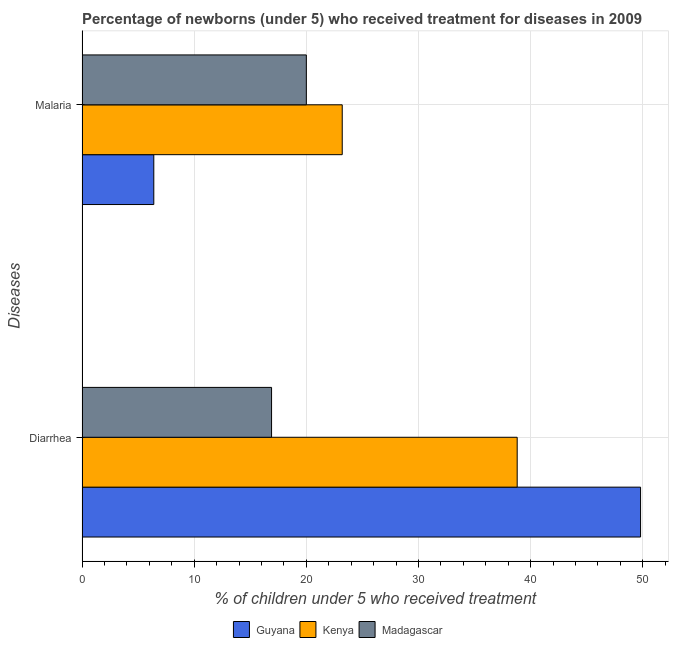How many different coloured bars are there?
Keep it short and to the point. 3. How many groups of bars are there?
Provide a succinct answer. 2. Are the number of bars per tick equal to the number of legend labels?
Your answer should be compact. Yes. Are the number of bars on each tick of the Y-axis equal?
Ensure brevity in your answer.  Yes. What is the label of the 2nd group of bars from the top?
Offer a terse response. Diarrhea. What is the percentage of children who received treatment for diarrhoea in Madagascar?
Your answer should be very brief. 16.9. Across all countries, what is the maximum percentage of children who received treatment for diarrhoea?
Your response must be concise. 49.8. In which country was the percentage of children who received treatment for diarrhoea maximum?
Your answer should be very brief. Guyana. In which country was the percentage of children who received treatment for diarrhoea minimum?
Provide a short and direct response. Madagascar. What is the total percentage of children who received treatment for diarrhoea in the graph?
Your answer should be very brief. 105.5. What is the difference between the percentage of children who received treatment for diarrhoea in Guyana and that in Madagascar?
Your response must be concise. 32.9. What is the difference between the percentage of children who received treatment for diarrhoea in Madagascar and the percentage of children who received treatment for malaria in Kenya?
Offer a terse response. -6.3. What is the average percentage of children who received treatment for malaria per country?
Offer a terse response. 16.53. What is the difference between the percentage of children who received treatment for malaria and percentage of children who received treatment for diarrhoea in Madagascar?
Your answer should be very brief. 3.1. In how many countries, is the percentage of children who received treatment for diarrhoea greater than 48 %?
Ensure brevity in your answer.  1. What is the ratio of the percentage of children who received treatment for malaria in Guyana to that in Kenya?
Make the answer very short. 0.28. Is the percentage of children who received treatment for malaria in Kenya less than that in Madagascar?
Offer a terse response. No. In how many countries, is the percentage of children who received treatment for diarrhoea greater than the average percentage of children who received treatment for diarrhoea taken over all countries?
Give a very brief answer. 2. What does the 1st bar from the top in Diarrhea represents?
Provide a succinct answer. Madagascar. What does the 2nd bar from the bottom in Malaria represents?
Your answer should be very brief. Kenya. How many bars are there?
Provide a succinct answer. 6. Are all the bars in the graph horizontal?
Your response must be concise. Yes. What is the difference between two consecutive major ticks on the X-axis?
Keep it short and to the point. 10. Are the values on the major ticks of X-axis written in scientific E-notation?
Make the answer very short. No. Where does the legend appear in the graph?
Provide a short and direct response. Bottom center. How are the legend labels stacked?
Your response must be concise. Horizontal. What is the title of the graph?
Ensure brevity in your answer.  Percentage of newborns (under 5) who received treatment for diseases in 2009. Does "Turkey" appear as one of the legend labels in the graph?
Offer a terse response. No. What is the label or title of the X-axis?
Offer a very short reply. % of children under 5 who received treatment. What is the label or title of the Y-axis?
Your answer should be very brief. Diseases. What is the % of children under 5 who received treatment of Guyana in Diarrhea?
Offer a very short reply. 49.8. What is the % of children under 5 who received treatment of Kenya in Diarrhea?
Give a very brief answer. 38.8. What is the % of children under 5 who received treatment of Madagascar in Diarrhea?
Offer a terse response. 16.9. What is the % of children under 5 who received treatment of Guyana in Malaria?
Your answer should be very brief. 6.4. What is the % of children under 5 who received treatment of Kenya in Malaria?
Your answer should be compact. 23.2. Across all Diseases, what is the maximum % of children under 5 who received treatment in Guyana?
Give a very brief answer. 49.8. Across all Diseases, what is the maximum % of children under 5 who received treatment in Kenya?
Make the answer very short. 38.8. Across all Diseases, what is the minimum % of children under 5 who received treatment in Guyana?
Your answer should be compact. 6.4. Across all Diseases, what is the minimum % of children under 5 who received treatment of Kenya?
Your answer should be compact. 23.2. Across all Diseases, what is the minimum % of children under 5 who received treatment in Madagascar?
Give a very brief answer. 16.9. What is the total % of children under 5 who received treatment in Guyana in the graph?
Provide a short and direct response. 56.2. What is the total % of children under 5 who received treatment in Kenya in the graph?
Provide a succinct answer. 62. What is the total % of children under 5 who received treatment of Madagascar in the graph?
Offer a terse response. 36.9. What is the difference between the % of children under 5 who received treatment of Guyana in Diarrhea and that in Malaria?
Keep it short and to the point. 43.4. What is the difference between the % of children under 5 who received treatment of Kenya in Diarrhea and that in Malaria?
Your answer should be very brief. 15.6. What is the difference between the % of children under 5 who received treatment of Madagascar in Diarrhea and that in Malaria?
Offer a terse response. -3.1. What is the difference between the % of children under 5 who received treatment of Guyana in Diarrhea and the % of children under 5 who received treatment of Kenya in Malaria?
Give a very brief answer. 26.6. What is the difference between the % of children under 5 who received treatment of Guyana in Diarrhea and the % of children under 5 who received treatment of Madagascar in Malaria?
Your answer should be compact. 29.8. What is the difference between the % of children under 5 who received treatment in Kenya in Diarrhea and the % of children under 5 who received treatment in Madagascar in Malaria?
Provide a short and direct response. 18.8. What is the average % of children under 5 who received treatment in Guyana per Diseases?
Make the answer very short. 28.1. What is the average % of children under 5 who received treatment of Madagascar per Diseases?
Give a very brief answer. 18.45. What is the difference between the % of children under 5 who received treatment of Guyana and % of children under 5 who received treatment of Madagascar in Diarrhea?
Ensure brevity in your answer.  32.9. What is the difference between the % of children under 5 who received treatment of Kenya and % of children under 5 who received treatment of Madagascar in Diarrhea?
Give a very brief answer. 21.9. What is the difference between the % of children under 5 who received treatment of Guyana and % of children under 5 who received treatment of Kenya in Malaria?
Your answer should be very brief. -16.8. What is the difference between the % of children under 5 who received treatment of Kenya and % of children under 5 who received treatment of Madagascar in Malaria?
Your answer should be very brief. 3.2. What is the ratio of the % of children under 5 who received treatment of Guyana in Diarrhea to that in Malaria?
Give a very brief answer. 7.78. What is the ratio of the % of children under 5 who received treatment in Kenya in Diarrhea to that in Malaria?
Provide a short and direct response. 1.67. What is the ratio of the % of children under 5 who received treatment of Madagascar in Diarrhea to that in Malaria?
Your answer should be very brief. 0.84. What is the difference between the highest and the second highest % of children under 5 who received treatment of Guyana?
Make the answer very short. 43.4. What is the difference between the highest and the second highest % of children under 5 who received treatment of Kenya?
Your response must be concise. 15.6. What is the difference between the highest and the second highest % of children under 5 who received treatment of Madagascar?
Offer a very short reply. 3.1. What is the difference between the highest and the lowest % of children under 5 who received treatment in Guyana?
Your answer should be compact. 43.4. What is the difference between the highest and the lowest % of children under 5 who received treatment of Kenya?
Give a very brief answer. 15.6. 